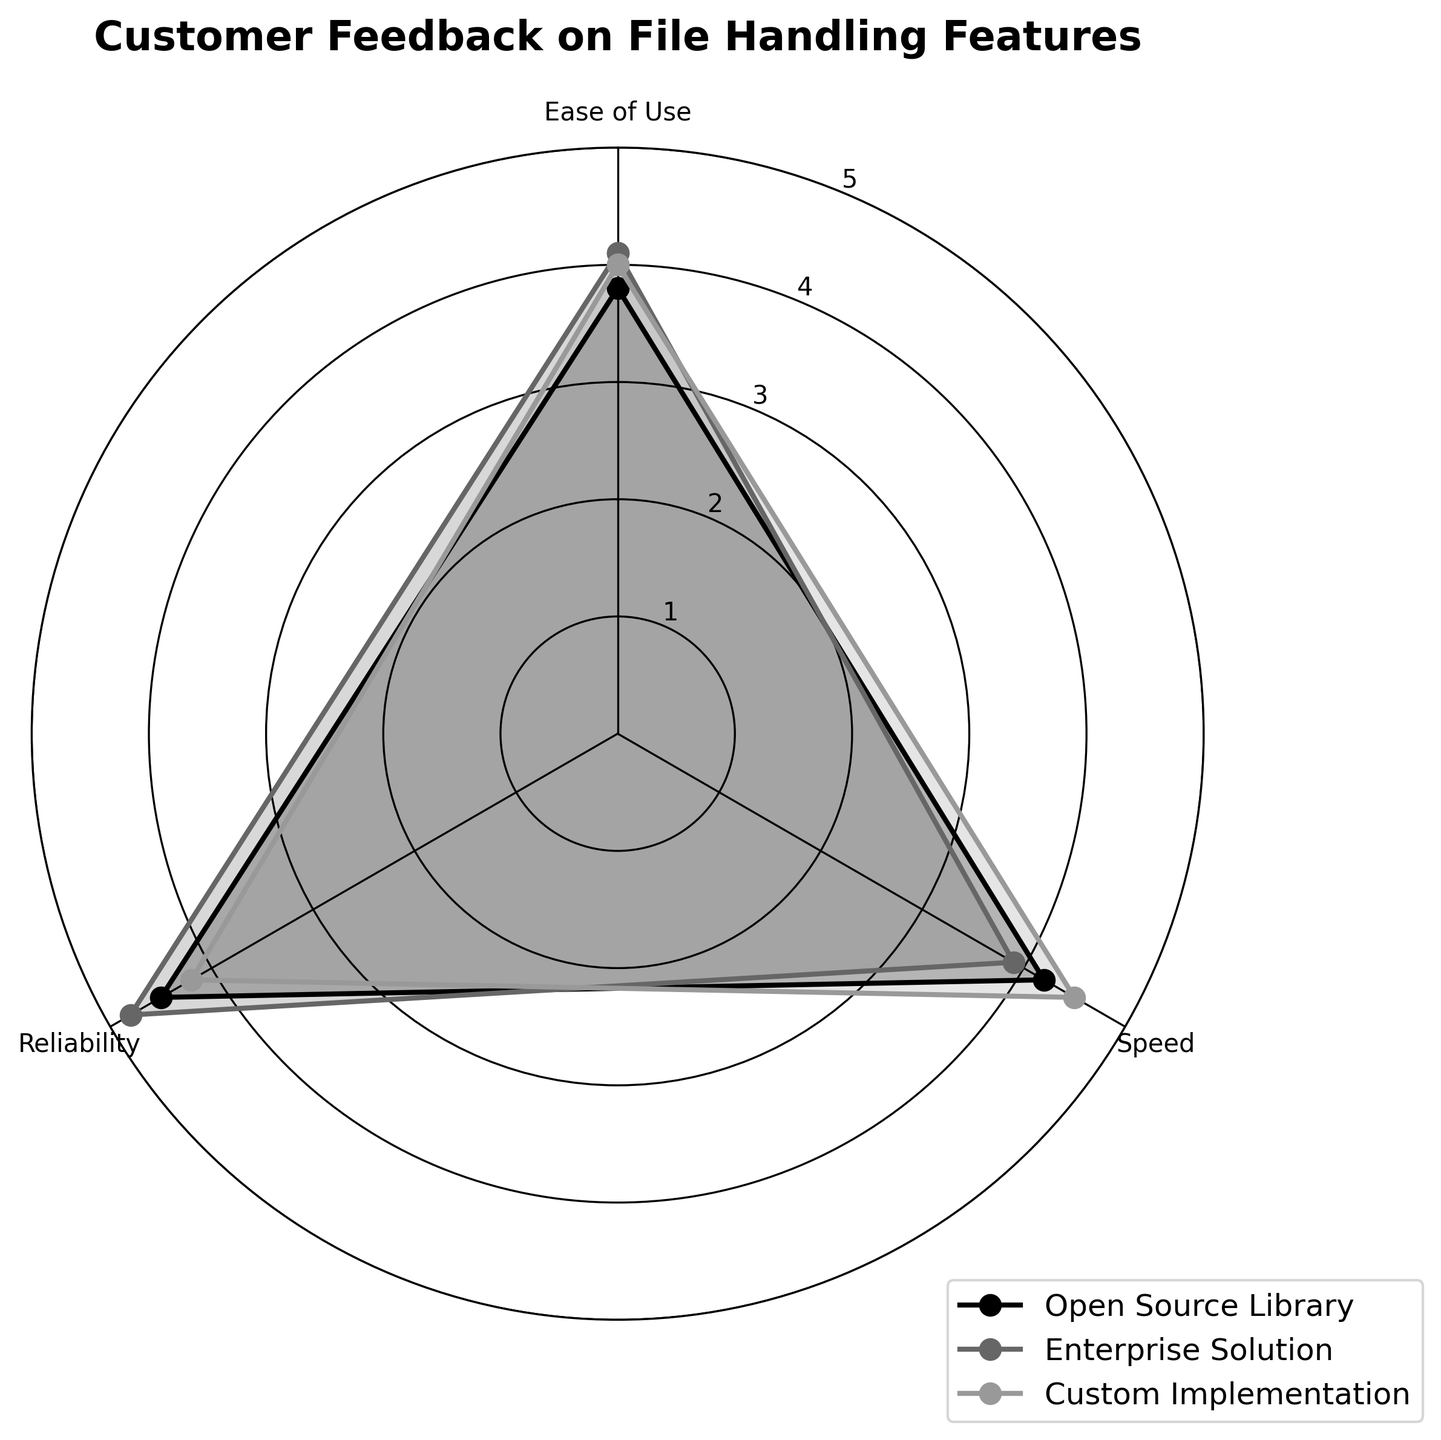What is the title of the radar chart? The title of the radar chart is displayed at the top of the figure.
Answer: Customer Feedback on File Handling Features Which feature has the highest rating for the Open Source Library group? By visually inspecting the data points for the Open Source Library group, observe the highest value reached.
Answer: Reliability What is the range of the y-axis on the radar chart? Look at the circular grid labels to understand the y-axis range.
Answer: 0 to 5 How does the Speed rating of the Enterprise Solution group compare to that of the Custom Implementation group? Identify and compare the Speed rating for both groups from their respective points.
Answer: Lower Which group has the highest Ease of Use rating? Compare the Ease of Use ratings across all groups and identify the highest one.
Answer: Enterprise Solution What is the average rating for the Custom Implementation group across all features? Add up the three ratings for Custom Implementation (Ease of Use, Speed, Reliability) and divide by 3.
Answer: 4.23 Which group has the smallest deviation among the features? Observe and calculate the difference between the highest and lowest ratings within each group to find the smallest range.
Answer: Enterprise Solution Are any of the Ease of Use ratings equal across groups? Examine the Ease of Use ratings for all groups and check if any two or more are the same.
Answer: No Which feature has the most consistent feedback across all groups? Compare the range (difference between max and min ratings) of each feature across all groups and identify the smallest range.
Answer: Ease of Use 